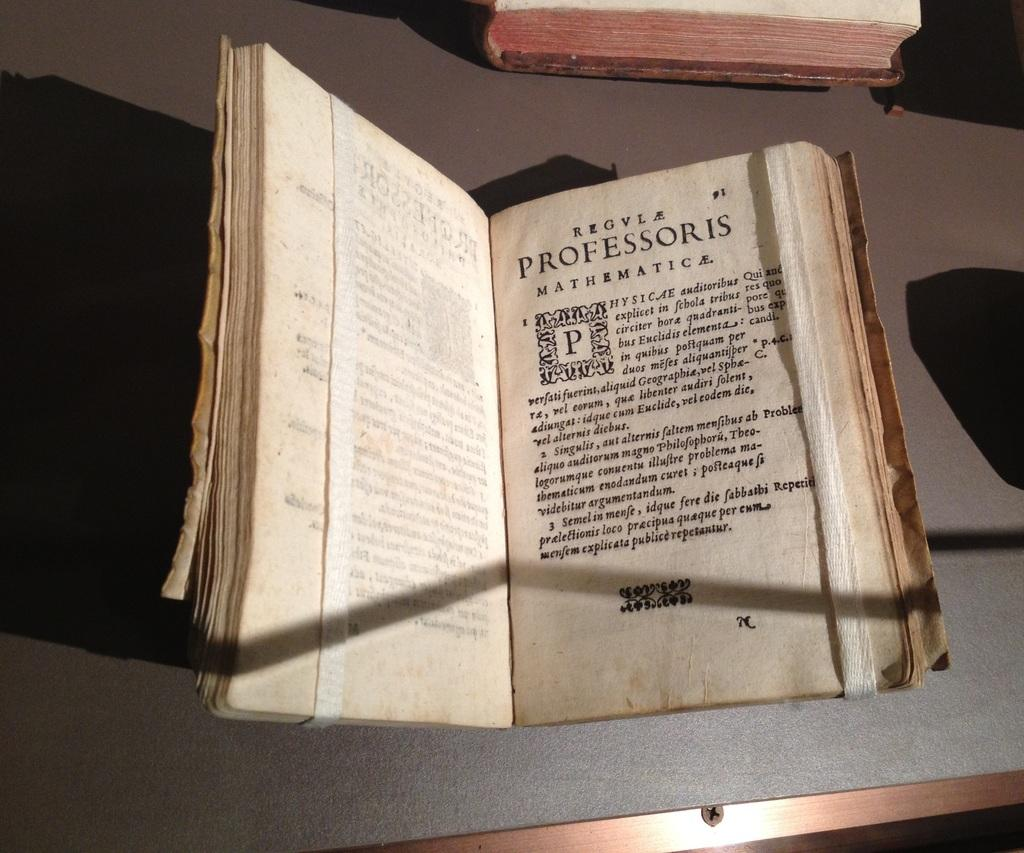<image>
Summarize the visual content of the image. A mathematics book written in Latin is laying open on a table. 